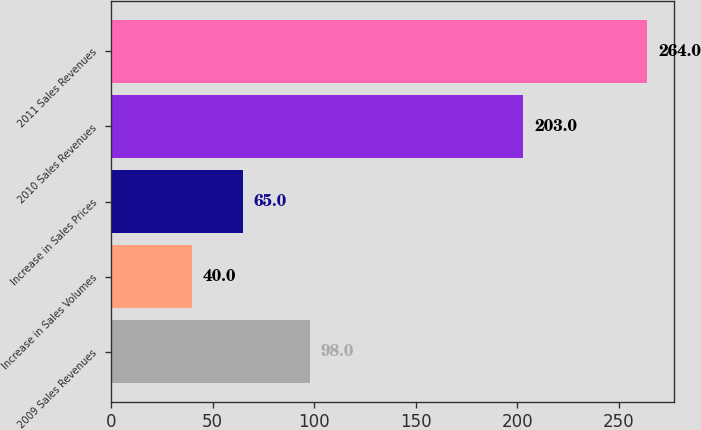<chart> <loc_0><loc_0><loc_500><loc_500><bar_chart><fcel>2009 Sales Revenues<fcel>Increase in Sales Volumes<fcel>Increase in Sales Prices<fcel>2010 Sales Revenues<fcel>2011 Sales Revenues<nl><fcel>98<fcel>40<fcel>65<fcel>203<fcel>264<nl></chart> 